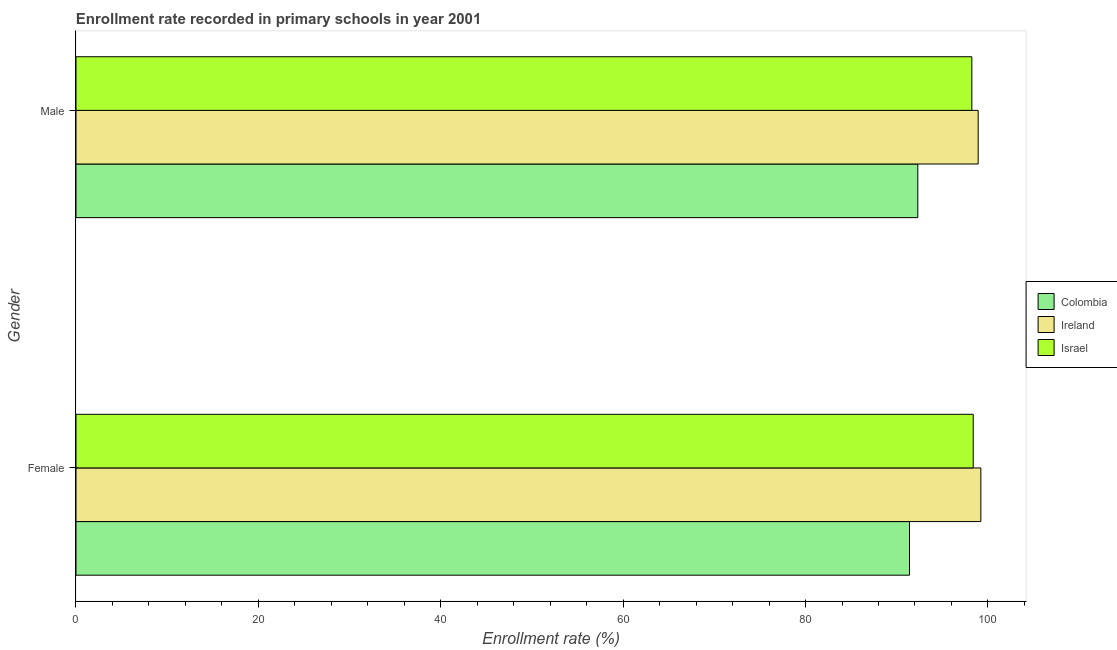How many different coloured bars are there?
Your answer should be very brief. 3. Are the number of bars on each tick of the Y-axis equal?
Provide a short and direct response. Yes. How many bars are there on the 1st tick from the top?
Provide a short and direct response. 3. How many bars are there on the 2nd tick from the bottom?
Make the answer very short. 3. What is the label of the 2nd group of bars from the top?
Make the answer very short. Female. What is the enrollment rate of male students in Colombia?
Ensure brevity in your answer.  92.31. Across all countries, what is the maximum enrollment rate of male students?
Offer a very short reply. 98.93. Across all countries, what is the minimum enrollment rate of female students?
Provide a succinct answer. 91.4. In which country was the enrollment rate of female students maximum?
Your response must be concise. Ireland. What is the total enrollment rate of female students in the graph?
Give a very brief answer. 289.01. What is the difference between the enrollment rate of female students in Israel and that in Colombia?
Make the answer very short. 6.99. What is the difference between the enrollment rate of female students in Colombia and the enrollment rate of male students in Ireland?
Provide a succinct answer. -7.53. What is the average enrollment rate of female students per country?
Provide a short and direct response. 96.34. What is the difference between the enrollment rate of male students and enrollment rate of female students in Ireland?
Provide a succinct answer. -0.29. What is the ratio of the enrollment rate of male students in Colombia to that in Ireland?
Provide a short and direct response. 0.93. What does the 1st bar from the top in Female represents?
Give a very brief answer. Israel. What does the 1st bar from the bottom in Male represents?
Your answer should be compact. Colombia. Are all the bars in the graph horizontal?
Your answer should be very brief. Yes. What is the difference between two consecutive major ticks on the X-axis?
Your answer should be compact. 20. Are the values on the major ticks of X-axis written in scientific E-notation?
Your response must be concise. No. Does the graph contain grids?
Give a very brief answer. No. Where does the legend appear in the graph?
Your response must be concise. Center right. How many legend labels are there?
Give a very brief answer. 3. What is the title of the graph?
Your response must be concise. Enrollment rate recorded in primary schools in year 2001. What is the label or title of the X-axis?
Offer a very short reply. Enrollment rate (%). What is the label or title of the Y-axis?
Keep it short and to the point. Gender. What is the Enrollment rate (%) in Colombia in Female?
Offer a terse response. 91.4. What is the Enrollment rate (%) in Ireland in Female?
Keep it short and to the point. 99.22. What is the Enrollment rate (%) of Israel in Female?
Offer a terse response. 98.39. What is the Enrollment rate (%) in Colombia in Male?
Make the answer very short. 92.31. What is the Enrollment rate (%) in Ireland in Male?
Your answer should be very brief. 98.93. What is the Enrollment rate (%) of Israel in Male?
Give a very brief answer. 98.24. Across all Gender, what is the maximum Enrollment rate (%) of Colombia?
Offer a very short reply. 92.31. Across all Gender, what is the maximum Enrollment rate (%) of Ireland?
Offer a terse response. 99.22. Across all Gender, what is the maximum Enrollment rate (%) in Israel?
Your response must be concise. 98.39. Across all Gender, what is the minimum Enrollment rate (%) of Colombia?
Your answer should be compact. 91.4. Across all Gender, what is the minimum Enrollment rate (%) in Ireland?
Your answer should be compact. 98.93. Across all Gender, what is the minimum Enrollment rate (%) in Israel?
Offer a terse response. 98.24. What is the total Enrollment rate (%) in Colombia in the graph?
Provide a short and direct response. 183.71. What is the total Enrollment rate (%) in Ireland in the graph?
Offer a terse response. 198.15. What is the total Enrollment rate (%) in Israel in the graph?
Your response must be concise. 196.63. What is the difference between the Enrollment rate (%) in Colombia in Female and that in Male?
Your answer should be very brief. -0.91. What is the difference between the Enrollment rate (%) in Ireland in Female and that in Male?
Make the answer very short. 0.29. What is the difference between the Enrollment rate (%) in Israel in Female and that in Male?
Keep it short and to the point. 0.15. What is the difference between the Enrollment rate (%) of Colombia in Female and the Enrollment rate (%) of Ireland in Male?
Give a very brief answer. -7.53. What is the difference between the Enrollment rate (%) of Colombia in Female and the Enrollment rate (%) of Israel in Male?
Provide a short and direct response. -6.84. What is the average Enrollment rate (%) in Colombia per Gender?
Provide a short and direct response. 91.86. What is the average Enrollment rate (%) of Ireland per Gender?
Ensure brevity in your answer.  99.08. What is the average Enrollment rate (%) in Israel per Gender?
Give a very brief answer. 98.31. What is the difference between the Enrollment rate (%) in Colombia and Enrollment rate (%) in Ireland in Female?
Give a very brief answer. -7.82. What is the difference between the Enrollment rate (%) of Colombia and Enrollment rate (%) of Israel in Female?
Provide a short and direct response. -6.99. What is the difference between the Enrollment rate (%) of Ireland and Enrollment rate (%) of Israel in Female?
Your answer should be compact. 0.84. What is the difference between the Enrollment rate (%) of Colombia and Enrollment rate (%) of Ireland in Male?
Make the answer very short. -6.62. What is the difference between the Enrollment rate (%) in Colombia and Enrollment rate (%) in Israel in Male?
Ensure brevity in your answer.  -5.92. What is the difference between the Enrollment rate (%) of Ireland and Enrollment rate (%) of Israel in Male?
Ensure brevity in your answer.  0.69. What is the ratio of the Enrollment rate (%) in Colombia in Female to that in Male?
Keep it short and to the point. 0.99. What is the ratio of the Enrollment rate (%) in Ireland in Female to that in Male?
Keep it short and to the point. 1. What is the difference between the highest and the second highest Enrollment rate (%) of Colombia?
Keep it short and to the point. 0.91. What is the difference between the highest and the second highest Enrollment rate (%) in Ireland?
Your response must be concise. 0.29. What is the difference between the highest and the second highest Enrollment rate (%) in Israel?
Your answer should be compact. 0.15. What is the difference between the highest and the lowest Enrollment rate (%) in Colombia?
Make the answer very short. 0.91. What is the difference between the highest and the lowest Enrollment rate (%) in Ireland?
Offer a very short reply. 0.29. What is the difference between the highest and the lowest Enrollment rate (%) in Israel?
Your response must be concise. 0.15. 